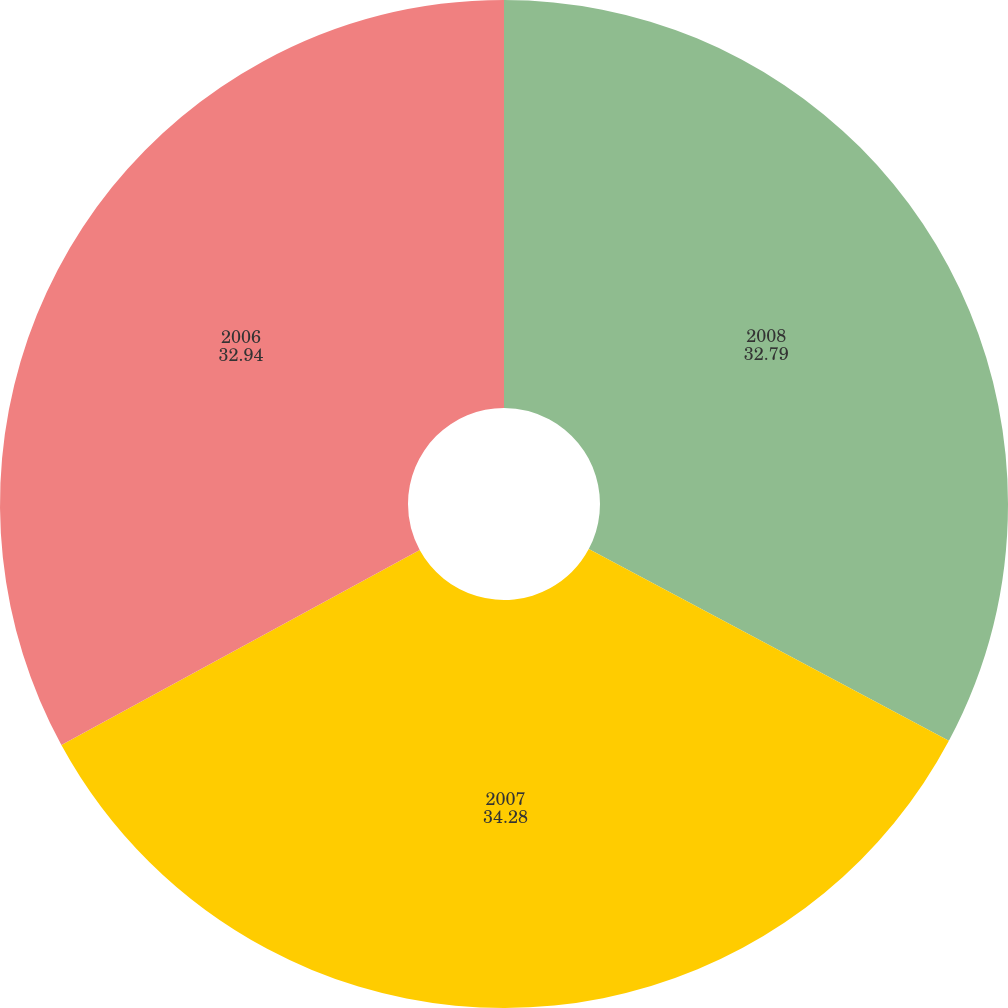Convert chart to OTSL. <chart><loc_0><loc_0><loc_500><loc_500><pie_chart><fcel>2008<fcel>2007<fcel>2006<nl><fcel>32.79%<fcel>34.28%<fcel>32.94%<nl></chart> 